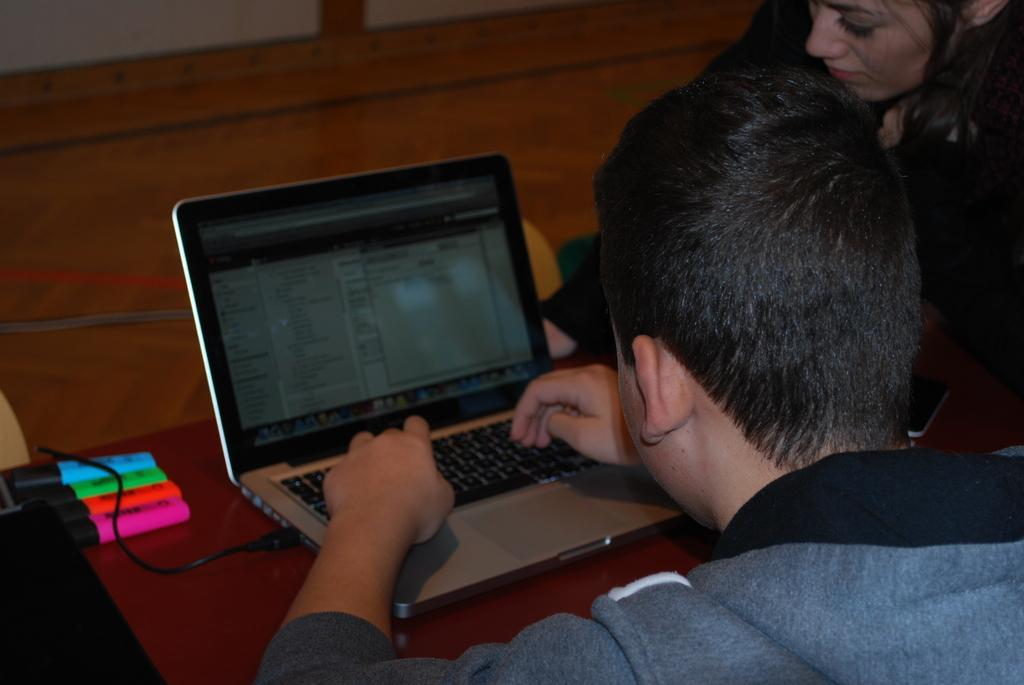How many people are in the image? There are two people in the image. What colors are the dresses of the people in the image? One person is wearing a black dress, and the other is wearing an ash color dress. What is in front of the people in the image? There is a table in front of the people. What electronic device is on the table? There is a laptop on the table. What other objects are on the table besides the laptop? There are other objects on the table. What type of insect is crawling on the laptop in the image? There is no insect present on the laptop or in the image. What month is it in the image? The image does not provide any information about the month or time of year. 